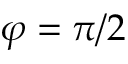<formula> <loc_0><loc_0><loc_500><loc_500>\varphi = \pi / 2</formula> 